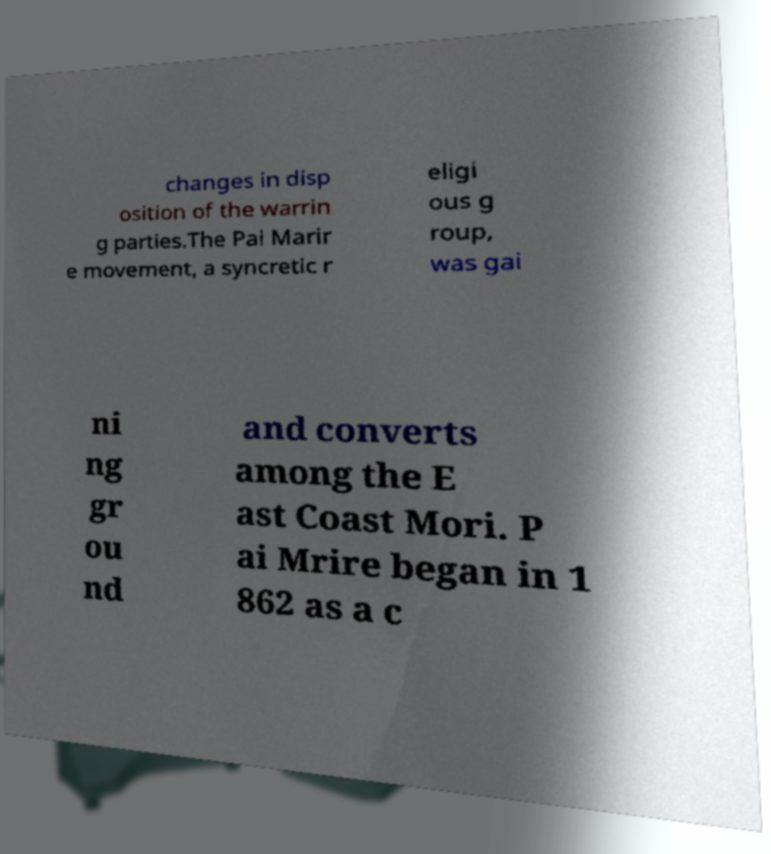I need the written content from this picture converted into text. Can you do that? changes in disp osition of the warrin g parties.The Pai Marir e movement, a syncretic r eligi ous g roup, was gai ni ng gr ou nd and converts among the E ast Coast Mori. P ai Mrire began in 1 862 as a c 